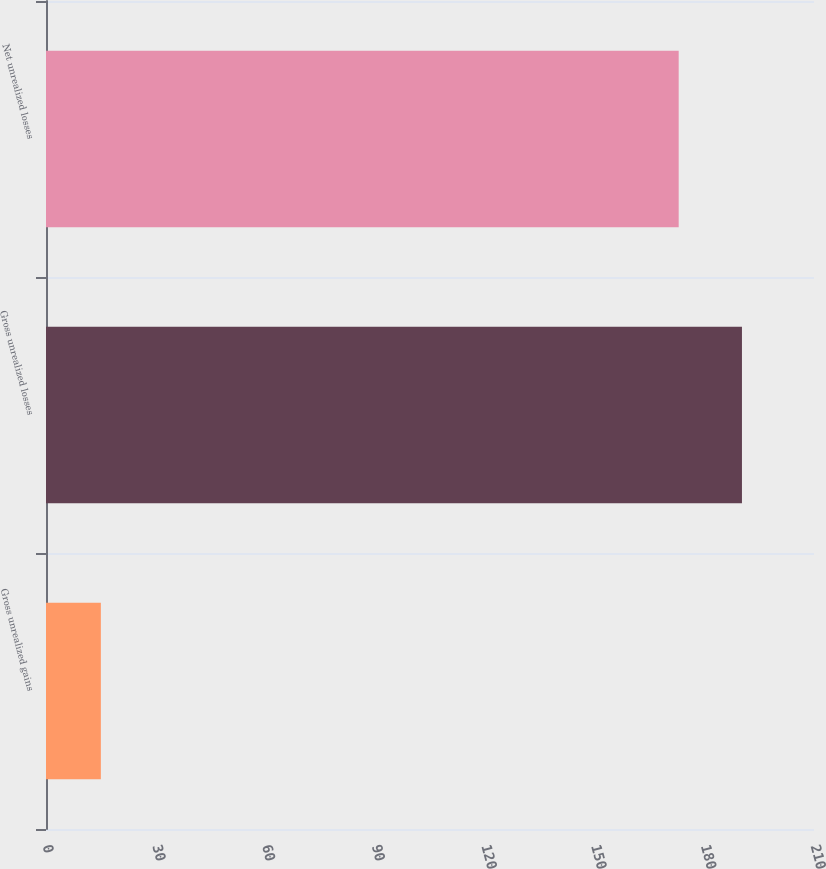Convert chart. <chart><loc_0><loc_0><loc_500><loc_500><bar_chart><fcel>Gross unrealized gains<fcel>Gross unrealized losses<fcel>Net unrealized losses<nl><fcel>15<fcel>190.3<fcel>173<nl></chart> 